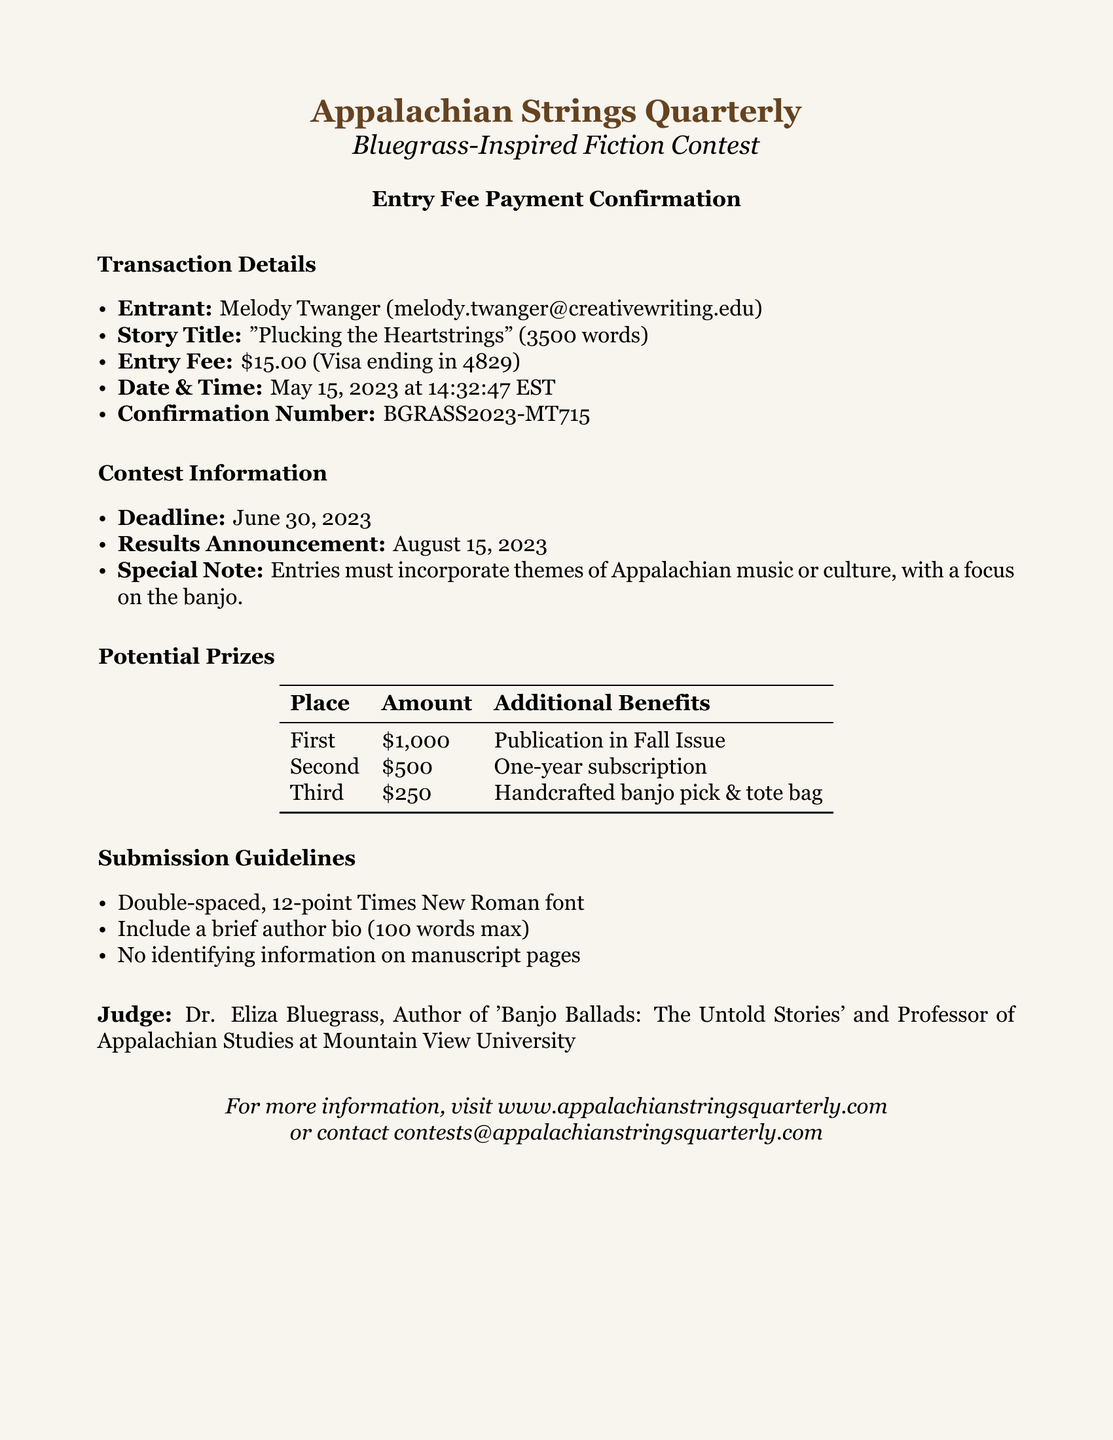What is the entrant's name? The entrant's name can be found in the transaction details section of the document.
Answer: Melody Twanger What is the entry fee amount? The entry fee is specified in the transaction details section of the document.
Answer: $15.00 What is the confirmation number? The confirmation number is listed under the transaction details as well.
Answer: BGRASS2023-MT715 What is the total prize money for the first place? The total prize money for the first place can be found in the potential prizes section.
Answer: $1,000 What are the special notes for the contest? The special notes provide guidelines on the theme requirements for entries and are found in the contest information section.
Answer: Entries must incorporate themes of Appalachian music or culture, with a focus on the banjo What is the story title submitted by the entrant? The story title is mentioned in the transaction details section of the document.
Answer: Plucking the Heartstrings Who is the judge for the contest? The judge's name and credentials are listed at the bottom of the document.
Answer: Dr. Eliza Bluegrass When is the contest results announcement date? The results announcement date is specified in the contest information section of the document.
Answer: August 15, 2023 How many words does the submitted story have? The word count is provided in the transaction details section of the document.
Answer: 3500 words 